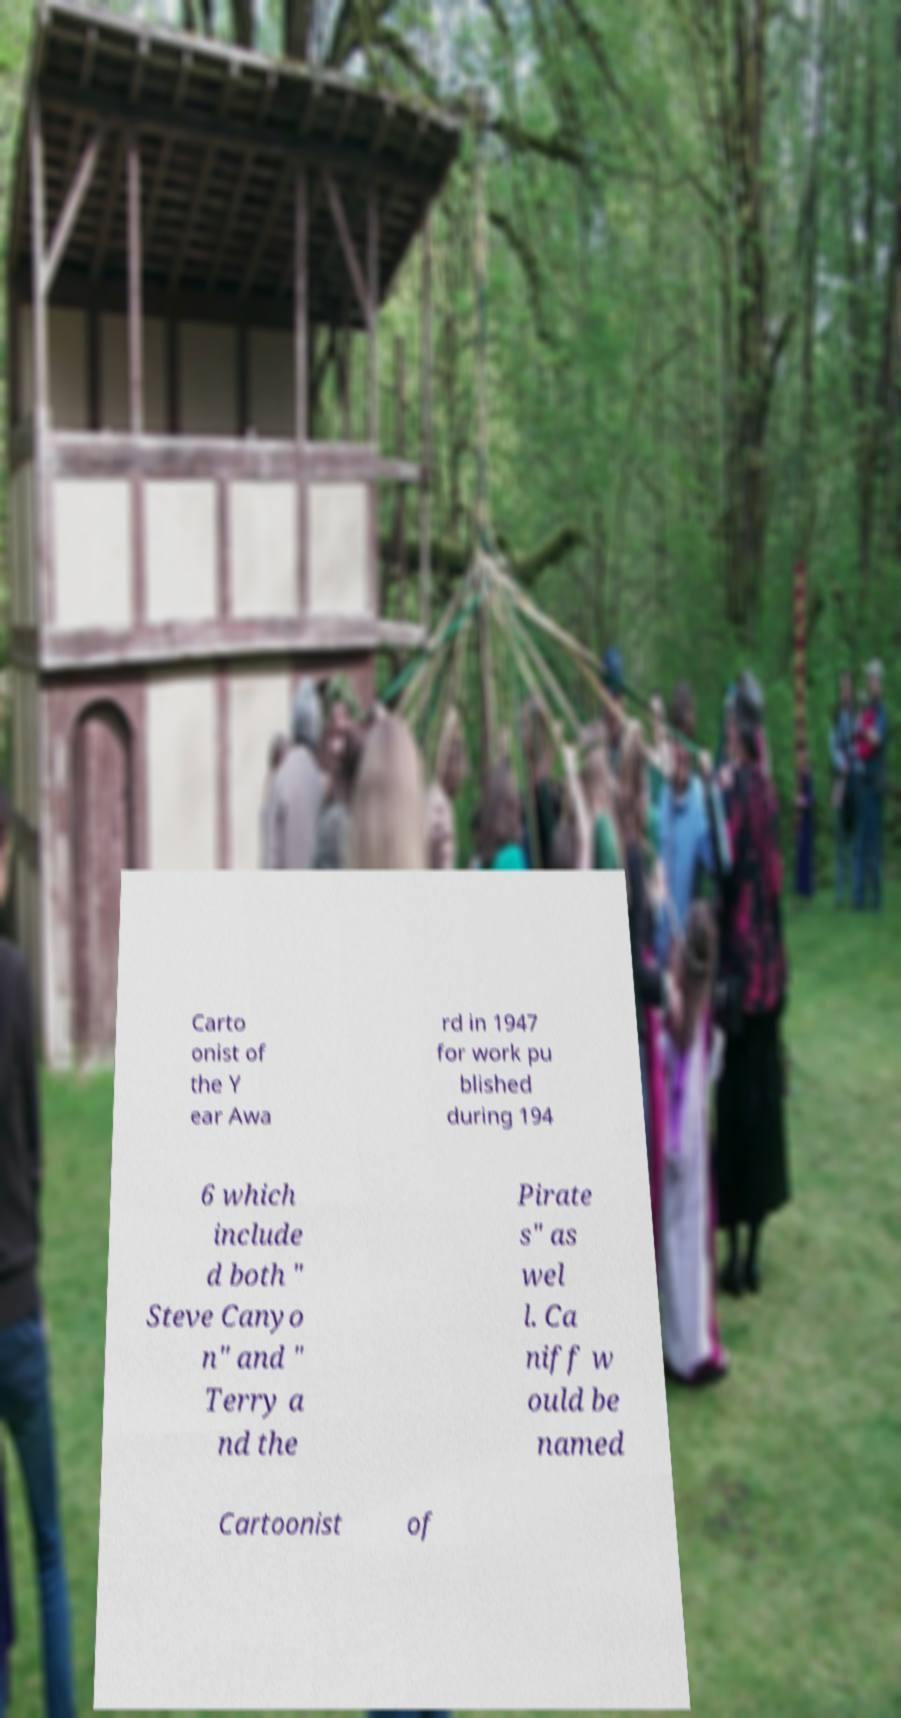Can you read and provide the text displayed in the image?This photo seems to have some interesting text. Can you extract and type it out for me? Carto onist of the Y ear Awa rd in 1947 for work pu blished during 194 6 which include d both " Steve Canyo n" and " Terry a nd the Pirate s" as wel l. Ca niff w ould be named Cartoonist of 